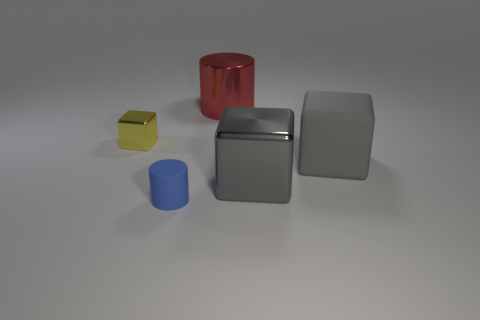Subtract all gray cubes. How many cubes are left? 1 Subtract all red balls. How many gray cubes are left? 2 Add 2 big rubber objects. How many objects exist? 7 Subtract all blocks. How many objects are left? 2 Subtract 1 cubes. How many cubes are left? 2 Add 5 blue cylinders. How many blue cylinders exist? 6 Subtract 0 blue spheres. How many objects are left? 5 Subtract all yellow cylinders. Subtract all yellow spheres. How many cylinders are left? 2 Subtract all purple metal things. Subtract all blocks. How many objects are left? 2 Add 3 yellow metal cubes. How many yellow metal cubes are left? 4 